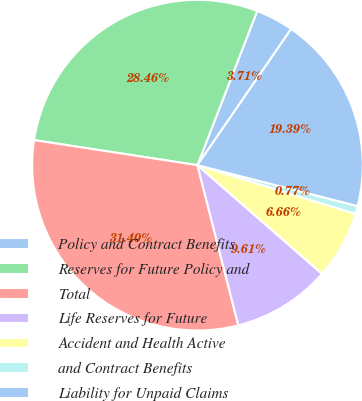<chart> <loc_0><loc_0><loc_500><loc_500><pie_chart><fcel>Policy and Contract Benefits<fcel>Reserves for Future Policy and<fcel>Total<fcel>Life Reserves for Future<fcel>Accident and Health Active<fcel>and Contract Benefits<fcel>Liability for Unpaid Claims<nl><fcel>3.71%<fcel>28.46%<fcel>31.4%<fcel>9.61%<fcel>6.66%<fcel>0.77%<fcel>19.39%<nl></chart> 